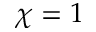<formula> <loc_0><loc_0><loc_500><loc_500>\chi = 1</formula> 